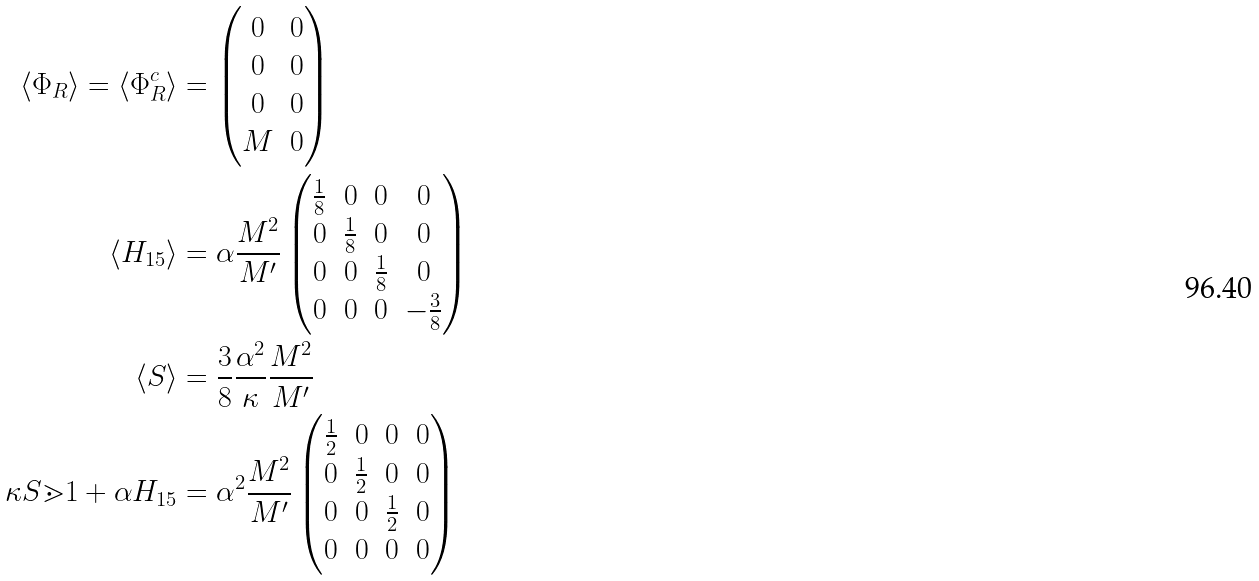Convert formula to latex. <formula><loc_0><loc_0><loc_500><loc_500>\langle \Phi _ { R } \rangle = \langle \Phi _ { R } ^ { c } \rangle & = \begin{pmatrix} 0 & 0 \\ 0 & 0 \\ 0 & 0 \\ M & 0 \end{pmatrix} \\ \langle H _ { 1 5 } \rangle & = \alpha \frac { M ^ { 2 } } { M ^ { \prime } } \begin{pmatrix} \frac { 1 } { 8 } & 0 & 0 & 0 \\ 0 & \frac { 1 } { 8 } & 0 & 0 \\ 0 & 0 & \frac { 1 } { 8 } & 0 \\ 0 & 0 & 0 & - \frac { 3 } { 8 } \end{pmatrix} \\ \langle S \rangle & = \frac { 3 } { 8 } \frac { \alpha ^ { 2 } } { \kappa } \frac { M ^ { 2 } } { M ^ { \prime } } \\ \kappa S \mathbb { m } { 1 } + \alpha H _ { 1 5 } & = \alpha ^ { 2 } \frac { M ^ { 2 } } { M ^ { \prime } } \begin{pmatrix} \frac { 1 } { 2 } & 0 & 0 & 0 \\ 0 & \frac { 1 } { 2 } & 0 & 0 \\ 0 & 0 & \frac { 1 } { 2 } & 0 \\ 0 & 0 & 0 & 0 \end{pmatrix}</formula> 